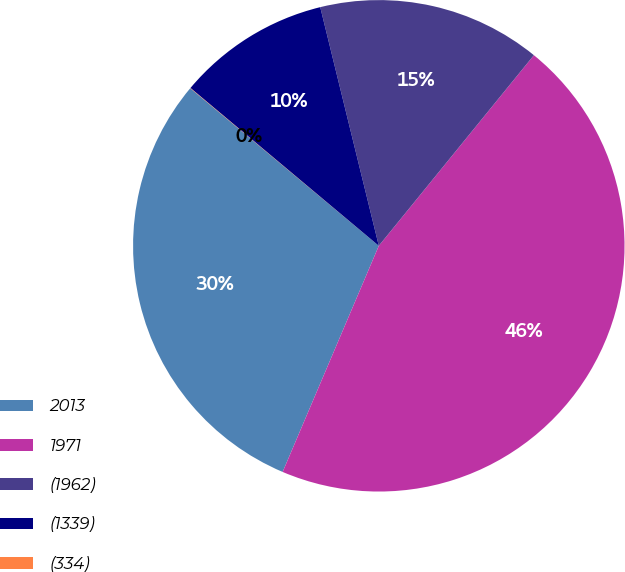Convert chart to OTSL. <chart><loc_0><loc_0><loc_500><loc_500><pie_chart><fcel>2013<fcel>1971<fcel>(1962)<fcel>(1339)<fcel>(334)<nl><fcel>29.68%<fcel>45.53%<fcel>14.7%<fcel>10.07%<fcel>0.02%<nl></chart> 